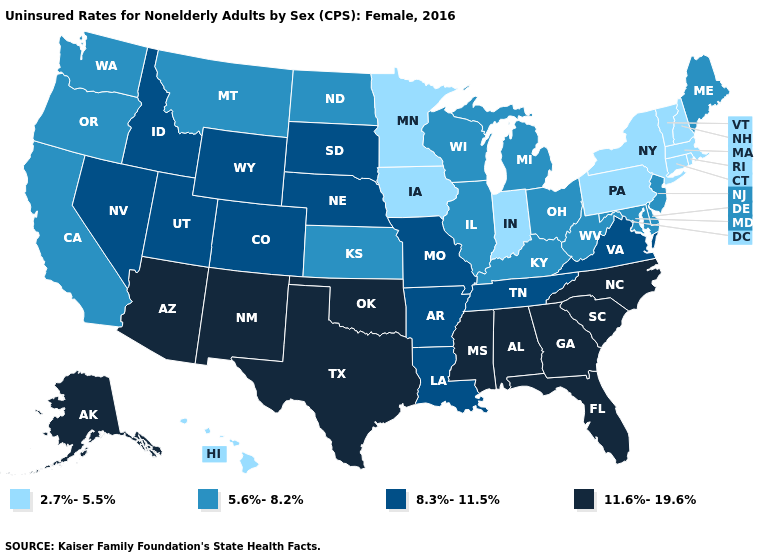Name the states that have a value in the range 11.6%-19.6%?
Answer briefly. Alabama, Alaska, Arizona, Florida, Georgia, Mississippi, New Mexico, North Carolina, Oklahoma, South Carolina, Texas. What is the highest value in the Northeast ?
Be succinct. 5.6%-8.2%. Does the first symbol in the legend represent the smallest category?
Concise answer only. Yes. Which states have the highest value in the USA?
Answer briefly. Alabama, Alaska, Arizona, Florida, Georgia, Mississippi, New Mexico, North Carolina, Oklahoma, South Carolina, Texas. What is the highest value in states that border Nevada?
Write a very short answer. 11.6%-19.6%. What is the lowest value in the South?
Write a very short answer. 5.6%-8.2%. Does North Dakota have a higher value than Idaho?
Answer briefly. No. Does Nevada have a lower value than Florida?
Answer briefly. Yes. What is the lowest value in the USA?
Give a very brief answer. 2.7%-5.5%. What is the value of Rhode Island?
Answer briefly. 2.7%-5.5%. What is the highest value in states that border New York?
Be succinct. 5.6%-8.2%. How many symbols are there in the legend?
Quick response, please. 4. What is the lowest value in the West?
Give a very brief answer. 2.7%-5.5%. Which states hav the highest value in the Northeast?
Be succinct. Maine, New Jersey. 